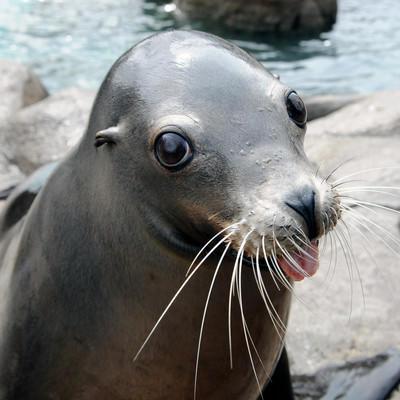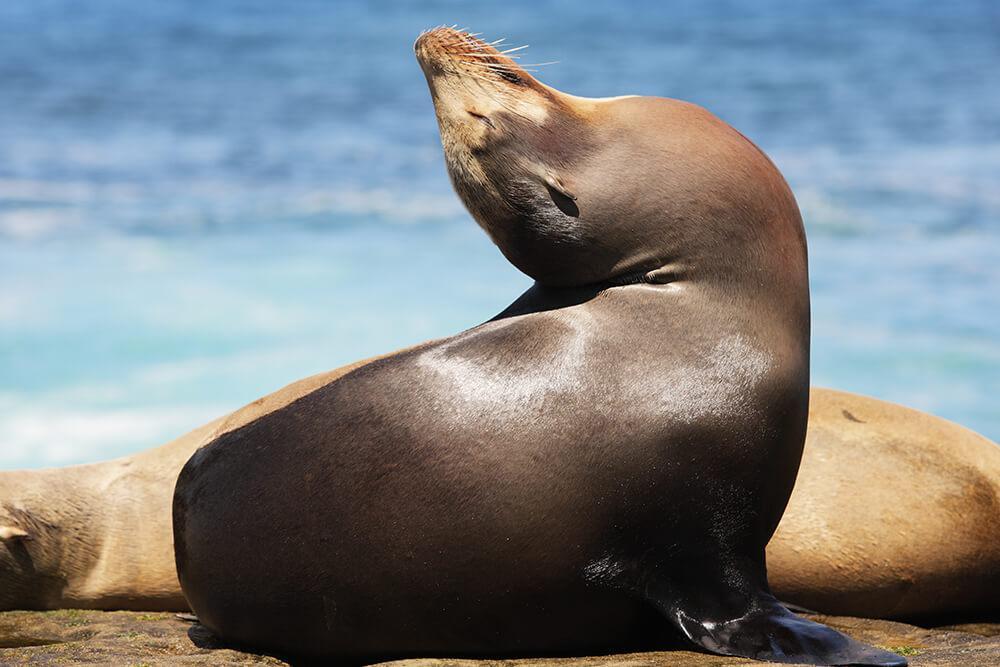The first image is the image on the left, the second image is the image on the right. Given the left and right images, does the statement "Two seals appear to be communicating face to face." hold true? Answer yes or no. No. The first image is the image on the left, the second image is the image on the right. Evaluate the accuracy of this statement regarding the images: "The lefthand image contains two different-sized seals, both with their heads upright.". Is it true? Answer yes or no. No. 